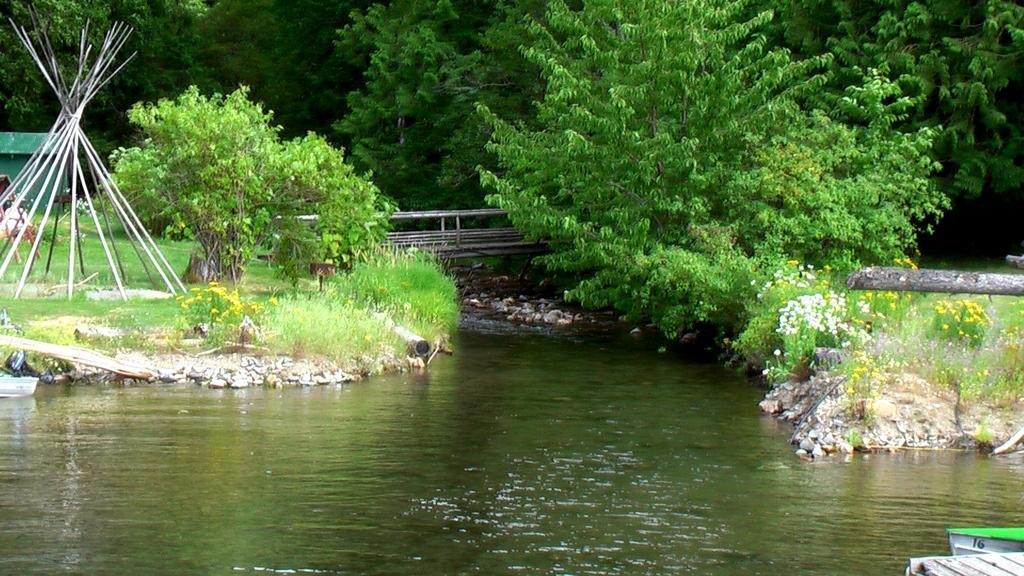What is on the water in the image? There are boats on the water in the image. What can be seen in the background of the image? There are flowers, trees, and a house visible in the background of the image. Where is your mom in the image? There is no person, including a mom, present in the image. What type of animal can be seen playing on the playground in the image? There is no playground or animal present in the image. 